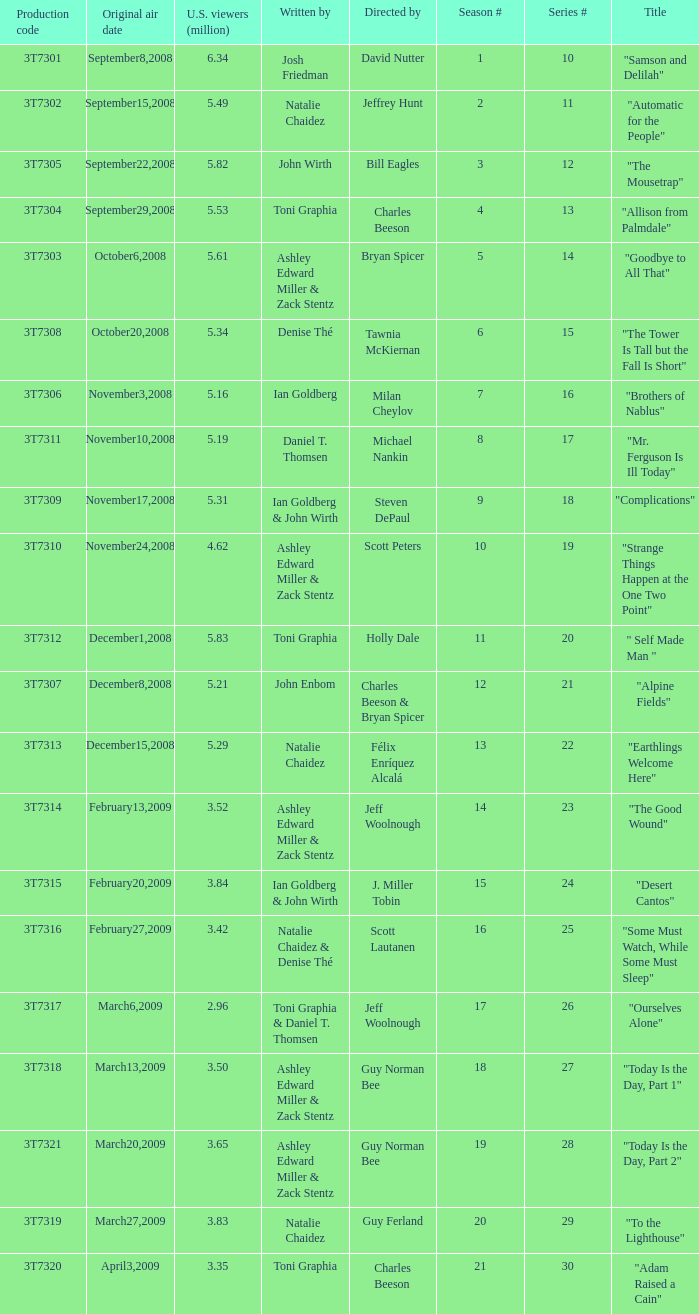Which episode number was directed by Bill Eagles? 12.0. 